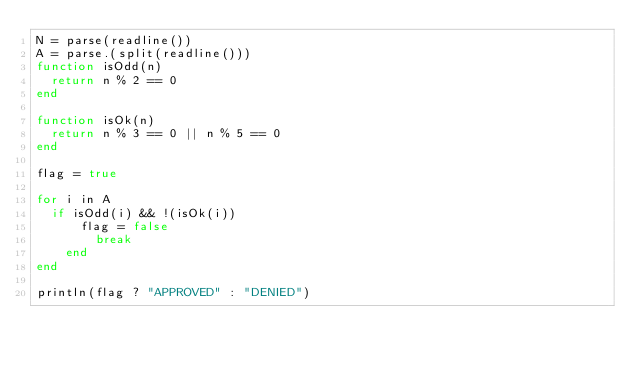<code> <loc_0><loc_0><loc_500><loc_500><_Julia_>N = parse(readline())
A = parse.(split(readline()))
function isOdd(n)
  return n % 2 == 0
end

function isOk(n)
  return n % 3 == 0 || n % 5 == 0
end
  
flag = true

for i in A
	if isOdd(i) && !(isOk(i))
    	flag = false
      	break
    end  
end    
  
println(flag ? "APPROVED" : "DENIED")
</code> 